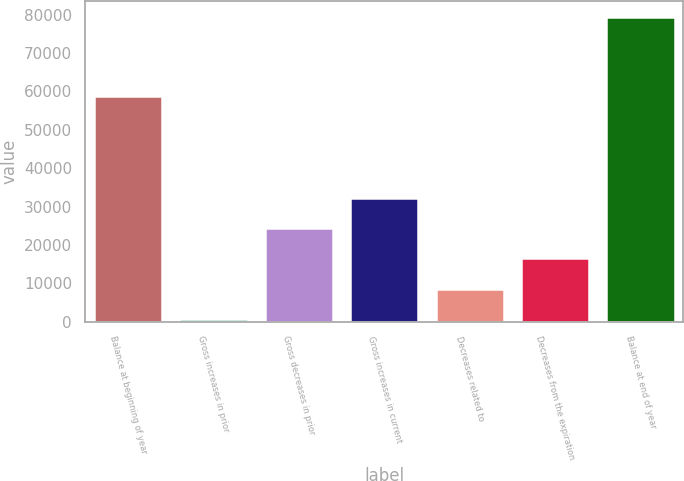Convert chart. <chart><loc_0><loc_0><loc_500><loc_500><bar_chart><fcel>Balance at beginning of year<fcel>Gross increases in prior<fcel>Gross decreases in prior<fcel>Gross increases in current<fcel>Decreases related to<fcel>Decreases from the expiration<fcel>Balance at end of year<nl><fcel>58855<fcel>803<fcel>24398.9<fcel>32264.2<fcel>8668.3<fcel>16533.6<fcel>79456<nl></chart> 